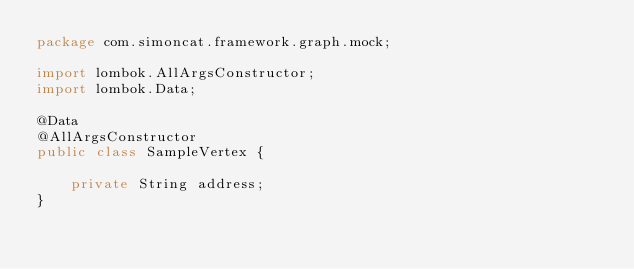Convert code to text. <code><loc_0><loc_0><loc_500><loc_500><_Java_>package com.simoncat.framework.graph.mock;

import lombok.AllArgsConstructor;
import lombok.Data;

@Data
@AllArgsConstructor
public class SampleVertex {

	private String address;
}
</code> 